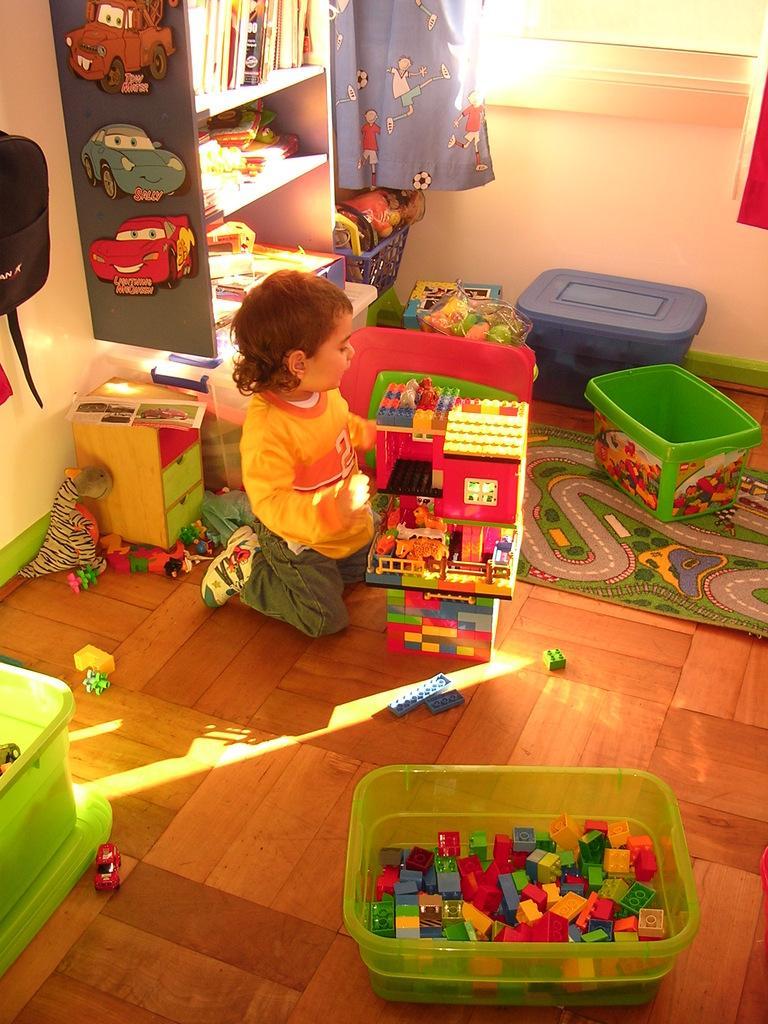Could you give a brief overview of what you see in this image? In the image we can see a baby wearing clothes and shoes. Here we can see toys, plastic containers and curtains. Here we can see books kept on the shelves, the wall and the window. 